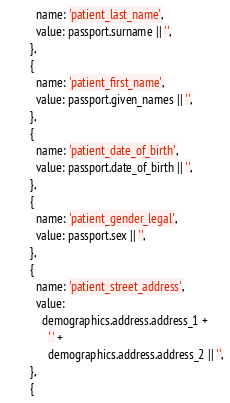<code> <loc_0><loc_0><loc_500><loc_500><_JavaScript_>          name: 'patient_last_name',
          value: passport.surname || '',
        },
        {
          name: 'patient_first_name',
          value: passport.given_names || '',
        },
        {
          name: 'patient_date_of_birth',
          value: passport.date_of_birth || '',
        },
        {
          name: 'patient_gender_legal',
          value: passport.sex || '',
        },
        {
          name: 'patient_street_address',
          value:
            demographics.address.address_1 +
              ' ' +
              demographics.address.address_2 || '',
        },
        {</code> 